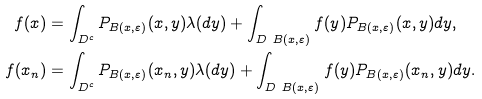<formula> <loc_0><loc_0><loc_500><loc_500>f ( x ) & = \int _ { D ^ { c } } P _ { B ( x , \varepsilon ) } ( x , y ) \lambda ( d y ) + \int _ { D \ B ( x , \varepsilon ) } f ( y ) P _ { B ( x , \varepsilon ) } ( x , y ) d y , \\ f ( x _ { n } ) & = \int _ { D ^ { c } } P _ { B ( x , \varepsilon ) } ( x _ { n } , y ) \lambda ( d y ) + \int _ { D \ B ( x , \varepsilon ) } f ( y ) P _ { B ( x , \varepsilon ) } ( x _ { n } , y ) d y .</formula> 